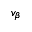<formula> <loc_0><loc_0><loc_500><loc_500>v _ { \beta }</formula> 